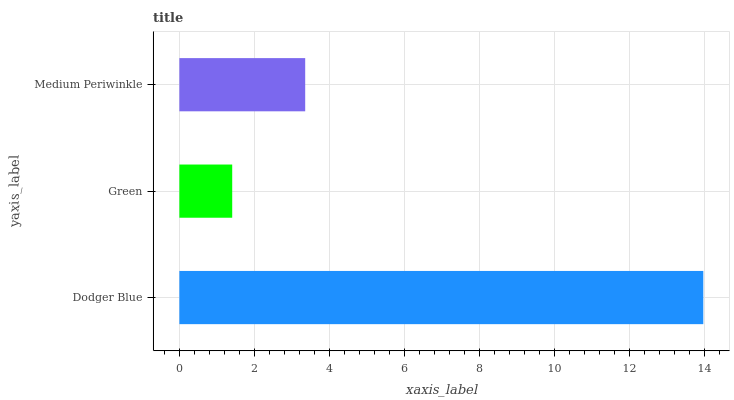Is Green the minimum?
Answer yes or no. Yes. Is Dodger Blue the maximum?
Answer yes or no. Yes. Is Medium Periwinkle the minimum?
Answer yes or no. No. Is Medium Periwinkle the maximum?
Answer yes or no. No. Is Medium Periwinkle greater than Green?
Answer yes or no. Yes. Is Green less than Medium Periwinkle?
Answer yes or no. Yes. Is Green greater than Medium Periwinkle?
Answer yes or no. No. Is Medium Periwinkle less than Green?
Answer yes or no. No. Is Medium Periwinkle the high median?
Answer yes or no. Yes. Is Medium Periwinkle the low median?
Answer yes or no. Yes. Is Dodger Blue the high median?
Answer yes or no. No. Is Green the low median?
Answer yes or no. No. 